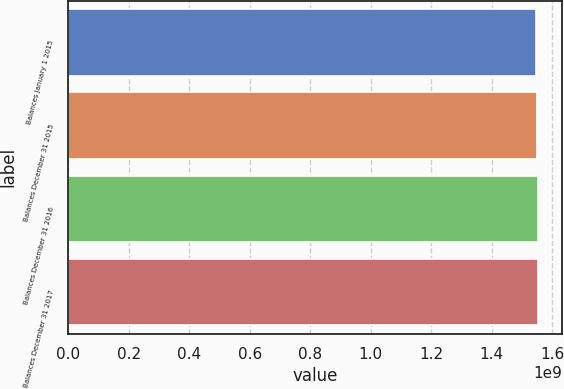Convert chart. <chart><loc_0><loc_0><loc_500><loc_500><bar_chart><fcel>Balances January 1 2015<fcel>Balances December 31 2015<fcel>Balances December 31 2016<fcel>Balances December 31 2017<nl><fcel>1.5469e+09<fcel>1.54934e+09<fcel>1.55139e+09<fcel>1.55322e+09<nl></chart> 